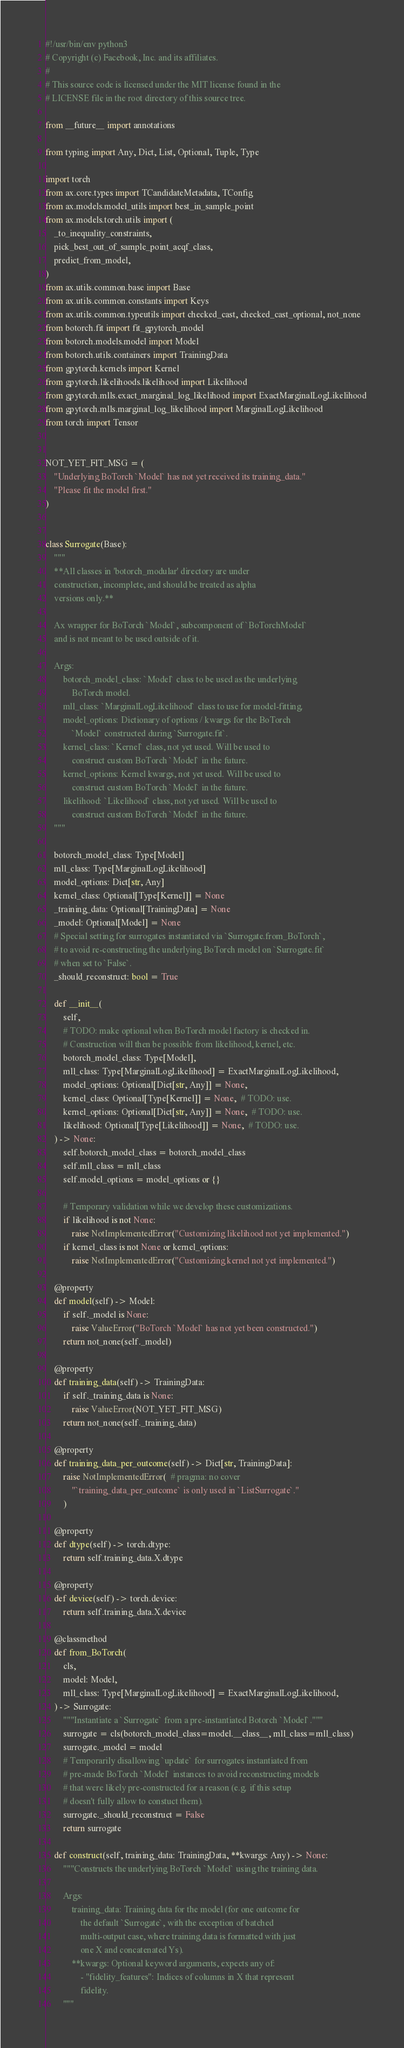<code> <loc_0><loc_0><loc_500><loc_500><_Python_>#!/usr/bin/env python3
# Copyright (c) Facebook, Inc. and its affiliates.
#
# This source code is licensed under the MIT license found in the
# LICENSE file in the root directory of this source tree.

from __future__ import annotations

from typing import Any, Dict, List, Optional, Tuple, Type

import torch
from ax.core.types import TCandidateMetadata, TConfig
from ax.models.model_utils import best_in_sample_point
from ax.models.torch.utils import (
    _to_inequality_constraints,
    pick_best_out_of_sample_point_acqf_class,
    predict_from_model,
)
from ax.utils.common.base import Base
from ax.utils.common.constants import Keys
from ax.utils.common.typeutils import checked_cast, checked_cast_optional, not_none
from botorch.fit import fit_gpytorch_model
from botorch.models.model import Model
from botorch.utils.containers import TrainingData
from gpytorch.kernels import Kernel
from gpytorch.likelihoods.likelihood import Likelihood
from gpytorch.mlls.exact_marginal_log_likelihood import ExactMarginalLogLikelihood
from gpytorch.mlls.marginal_log_likelihood import MarginalLogLikelihood
from torch import Tensor


NOT_YET_FIT_MSG = (
    "Underlying BoTorch `Model` has not yet received its training_data."
    "Please fit the model first."
)


class Surrogate(Base):
    """
    **All classes in 'botorch_modular' directory are under
    construction, incomplete, and should be treated as alpha
    versions only.**

    Ax wrapper for BoTorch `Model`, subcomponent of `BoTorchModel`
    and is not meant to be used outside of it.

    Args:
        botorch_model_class: `Model` class to be used as the underlying
            BoTorch model.
        mll_class: `MarginalLogLikelihood` class to use for model-fitting.
        model_options: Dictionary of options / kwargs for the BoTorch
            `Model` constructed during `Surrogate.fit`.
        kernel_class: `Kernel` class, not yet used. Will be used to
            construct custom BoTorch `Model` in the future.
        kernel_options: Kernel kwargs, not yet used. Will be used to
            construct custom BoTorch `Model` in the future.
        likelihood: `Likelihood` class, not yet used. Will be used to
            construct custom BoTorch `Model` in the future.
    """

    botorch_model_class: Type[Model]
    mll_class: Type[MarginalLogLikelihood]
    model_options: Dict[str, Any]
    kernel_class: Optional[Type[Kernel]] = None
    _training_data: Optional[TrainingData] = None
    _model: Optional[Model] = None
    # Special setting for surrogates instantiated via `Surrogate.from_BoTorch`,
    # to avoid re-constructing the underlying BoTorch model on `Surrogate.fit`
    # when set to `False`.
    _should_reconstruct: bool = True

    def __init__(
        self,
        # TODO: make optional when BoTorch model factory is checked in.
        # Construction will then be possible from likelihood, kernel, etc.
        botorch_model_class: Type[Model],
        mll_class: Type[MarginalLogLikelihood] = ExactMarginalLogLikelihood,
        model_options: Optional[Dict[str, Any]] = None,
        kernel_class: Optional[Type[Kernel]] = None,  # TODO: use.
        kernel_options: Optional[Dict[str, Any]] = None,  # TODO: use.
        likelihood: Optional[Type[Likelihood]] = None,  # TODO: use.
    ) -> None:
        self.botorch_model_class = botorch_model_class
        self.mll_class = mll_class
        self.model_options = model_options or {}

        # Temporary validation while we develop these customizations.
        if likelihood is not None:
            raise NotImplementedError("Customizing likelihood not yet implemented.")
        if kernel_class is not None or kernel_options:
            raise NotImplementedError("Customizing kernel not yet implemented.")

    @property
    def model(self) -> Model:
        if self._model is None:
            raise ValueError("BoTorch `Model` has not yet been constructed.")
        return not_none(self._model)

    @property
    def training_data(self) -> TrainingData:
        if self._training_data is None:
            raise ValueError(NOT_YET_FIT_MSG)
        return not_none(self._training_data)

    @property
    def training_data_per_outcome(self) -> Dict[str, TrainingData]:
        raise NotImplementedError(  # pragma: no cover
            "`training_data_per_outcome` is only used in `ListSurrogate`."
        )

    @property
    def dtype(self) -> torch.dtype:
        return self.training_data.X.dtype

    @property
    def device(self) -> torch.device:
        return self.training_data.X.device

    @classmethod
    def from_BoTorch(
        cls,
        model: Model,
        mll_class: Type[MarginalLogLikelihood] = ExactMarginalLogLikelihood,
    ) -> Surrogate:
        """Instantiate a `Surrogate` from a pre-instantiated Botorch `Model`."""
        surrogate = cls(botorch_model_class=model.__class__, mll_class=mll_class)
        surrogate._model = model
        # Temporarily disallowing `update` for surrogates instantiated from
        # pre-made BoTorch `Model` instances to avoid reconstructing models
        # that were likely pre-constructed for a reason (e.g. if this setup
        # doesn't fully allow to constuct them).
        surrogate._should_reconstruct = False
        return surrogate

    def construct(self, training_data: TrainingData, **kwargs: Any) -> None:
        """Constructs the underlying BoTorch `Model` using the training data.

        Args:
            training_data: Training data for the model (for one outcome for
                the default `Surrogate`, with the exception of batched
                multi-output case, where training data is formatted with just
                one X and concatenated Ys).
            **kwargs: Optional keyword arguments, expects any of:
                - "fidelity_features": Indices of columns in X that represent
                fidelity.
        """</code> 